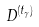Convert formula to latex. <formula><loc_0><loc_0><loc_500><loc_500>D ^ { ( t _ { \gamma } ) }</formula> 